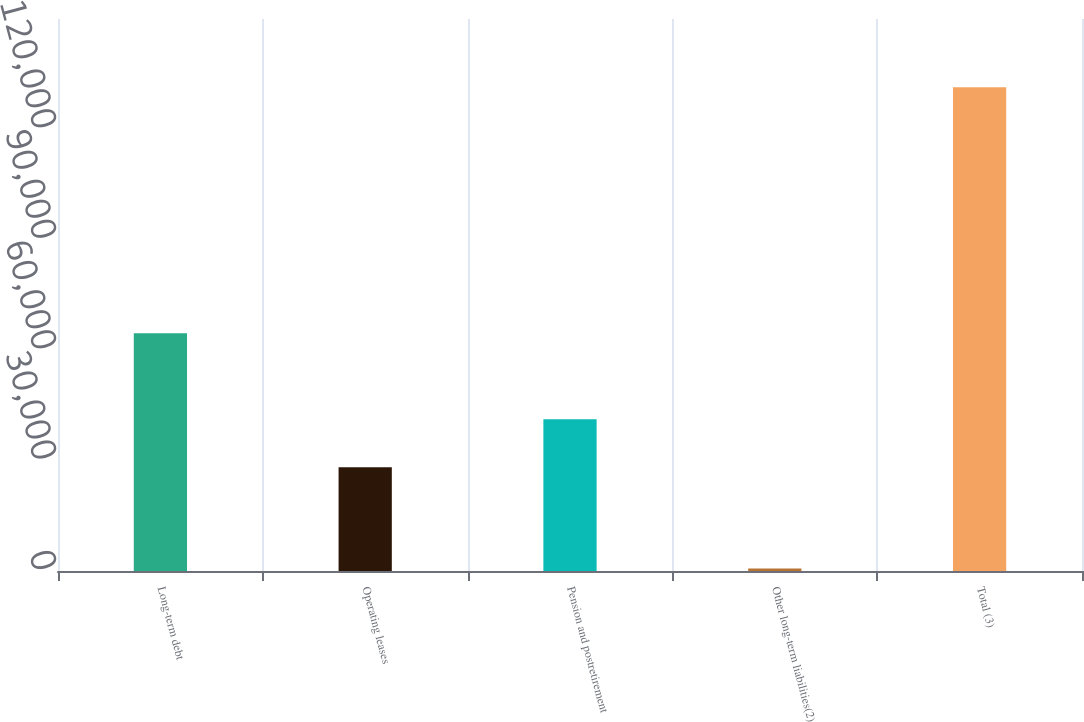<chart> <loc_0><loc_0><loc_500><loc_500><bar_chart><fcel>Long-term debt<fcel>Operating leases<fcel>Pension and postretirement<fcel>Other long-term liabilities(2)<fcel>Total (3)<nl><fcel>64623<fcel>28192<fcel>41266.8<fcel>678<fcel>131426<nl></chart> 